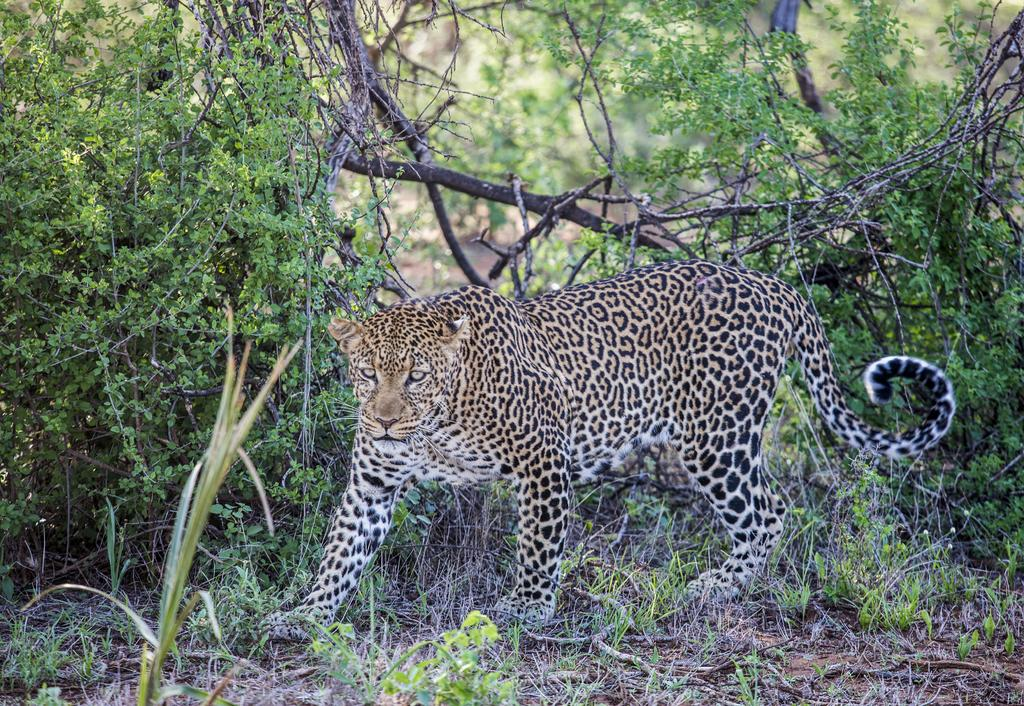What type of animal is in the image? There is a leopard in the image. What can be seen in the background of the image? There are plants in the background of the image. What type of mint can be seen growing near the leopard in the image? There is no mint present in the image, and the leopard is not near any plants that resemble mint. 